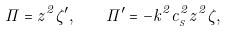<formula> <loc_0><loc_0><loc_500><loc_500>\Pi = z ^ { 2 } \zeta ^ { \prime } , \quad \Pi ^ { \prime } = - k ^ { 2 } c _ { _ { S } } ^ { 2 } z ^ { 2 } \zeta ,</formula> 